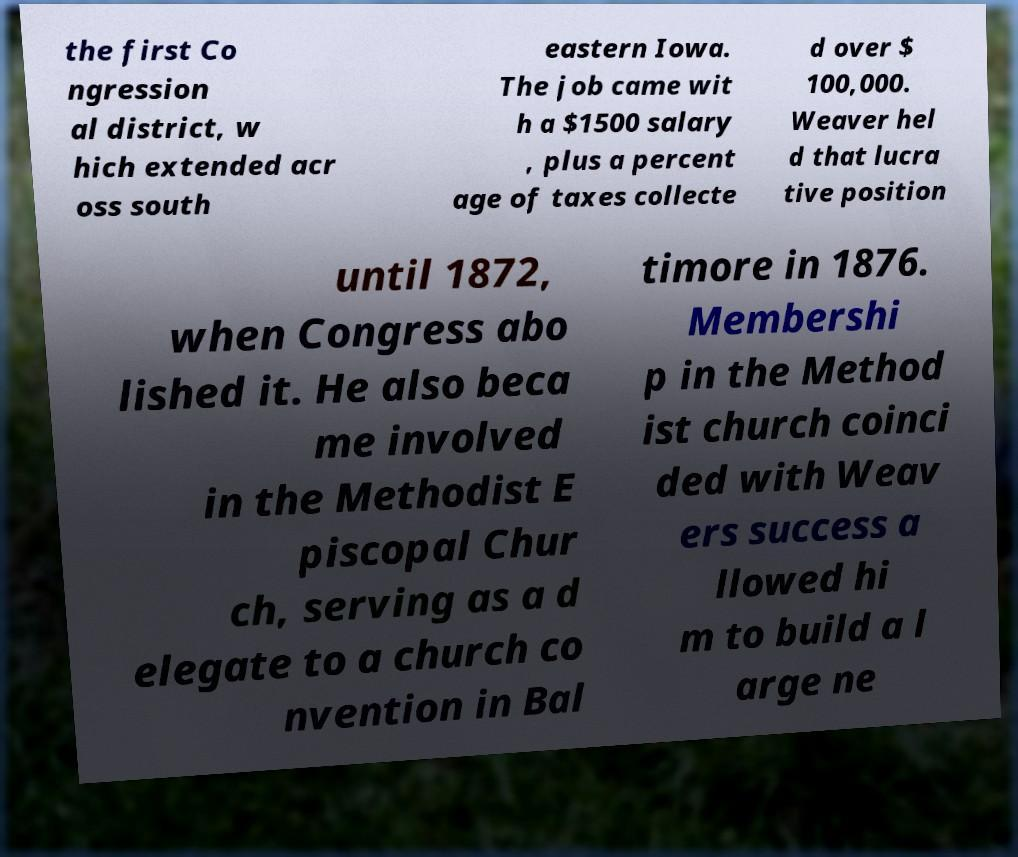What messages or text are displayed in this image? I need them in a readable, typed format. the first Co ngression al district, w hich extended acr oss south eastern Iowa. The job came wit h a $1500 salary , plus a percent age of taxes collecte d over $ 100,000. Weaver hel d that lucra tive position until 1872, when Congress abo lished it. He also beca me involved in the Methodist E piscopal Chur ch, serving as a d elegate to a church co nvention in Bal timore in 1876. Membershi p in the Method ist church coinci ded with Weav ers success a llowed hi m to build a l arge ne 